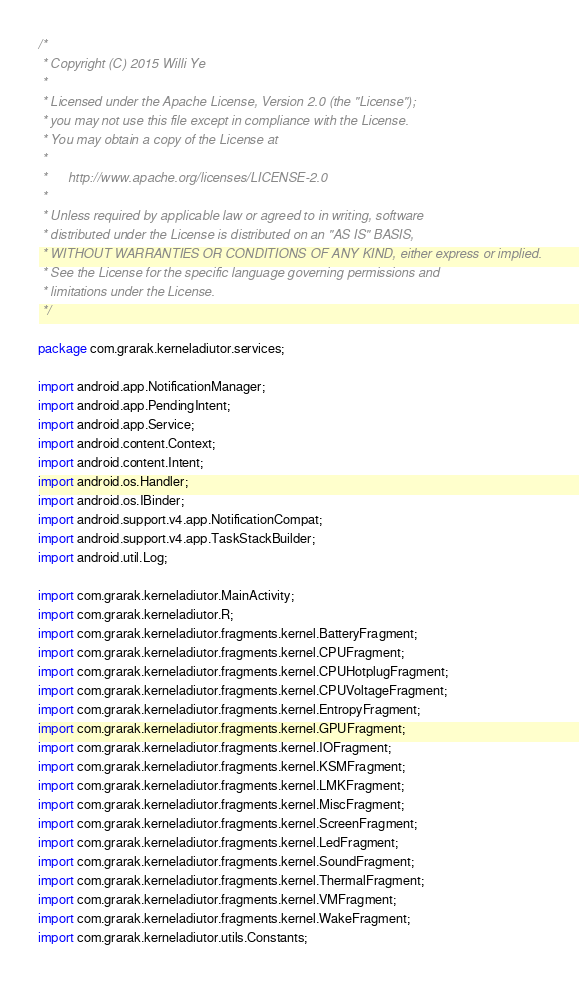Convert code to text. <code><loc_0><loc_0><loc_500><loc_500><_Java_>/*
 * Copyright (C) 2015 Willi Ye
 *
 * Licensed under the Apache License, Version 2.0 (the "License");
 * you may not use this file except in compliance with the License.
 * You may obtain a copy of the License at
 *
 *      http://www.apache.org/licenses/LICENSE-2.0
 *
 * Unless required by applicable law or agreed to in writing, software
 * distributed under the License is distributed on an "AS IS" BASIS,
 * WITHOUT WARRANTIES OR CONDITIONS OF ANY KIND, either express or implied.
 * See the License for the specific language governing permissions and
 * limitations under the License.
 */

package com.grarak.kerneladiutor.services;

import android.app.NotificationManager;
import android.app.PendingIntent;
import android.app.Service;
import android.content.Context;
import android.content.Intent;
import android.os.Handler;
import android.os.IBinder;
import android.support.v4.app.NotificationCompat;
import android.support.v4.app.TaskStackBuilder;
import android.util.Log;

import com.grarak.kerneladiutor.MainActivity;
import com.grarak.kerneladiutor.R;
import com.grarak.kerneladiutor.fragments.kernel.BatteryFragment;
import com.grarak.kerneladiutor.fragments.kernel.CPUFragment;
import com.grarak.kerneladiutor.fragments.kernel.CPUHotplugFragment;
import com.grarak.kerneladiutor.fragments.kernel.CPUVoltageFragment;
import com.grarak.kerneladiutor.fragments.kernel.EntropyFragment;
import com.grarak.kerneladiutor.fragments.kernel.GPUFragment;
import com.grarak.kerneladiutor.fragments.kernel.IOFragment;
import com.grarak.kerneladiutor.fragments.kernel.KSMFragment;
import com.grarak.kerneladiutor.fragments.kernel.LMKFragment;
import com.grarak.kerneladiutor.fragments.kernel.MiscFragment;
import com.grarak.kerneladiutor.fragments.kernel.ScreenFragment;
import com.grarak.kerneladiutor.fragments.kernel.LedFragment;
import com.grarak.kerneladiutor.fragments.kernel.SoundFragment;
import com.grarak.kerneladiutor.fragments.kernel.ThermalFragment;
import com.grarak.kerneladiutor.fragments.kernel.VMFragment;
import com.grarak.kerneladiutor.fragments.kernel.WakeFragment;
import com.grarak.kerneladiutor.utils.Constants;</code> 